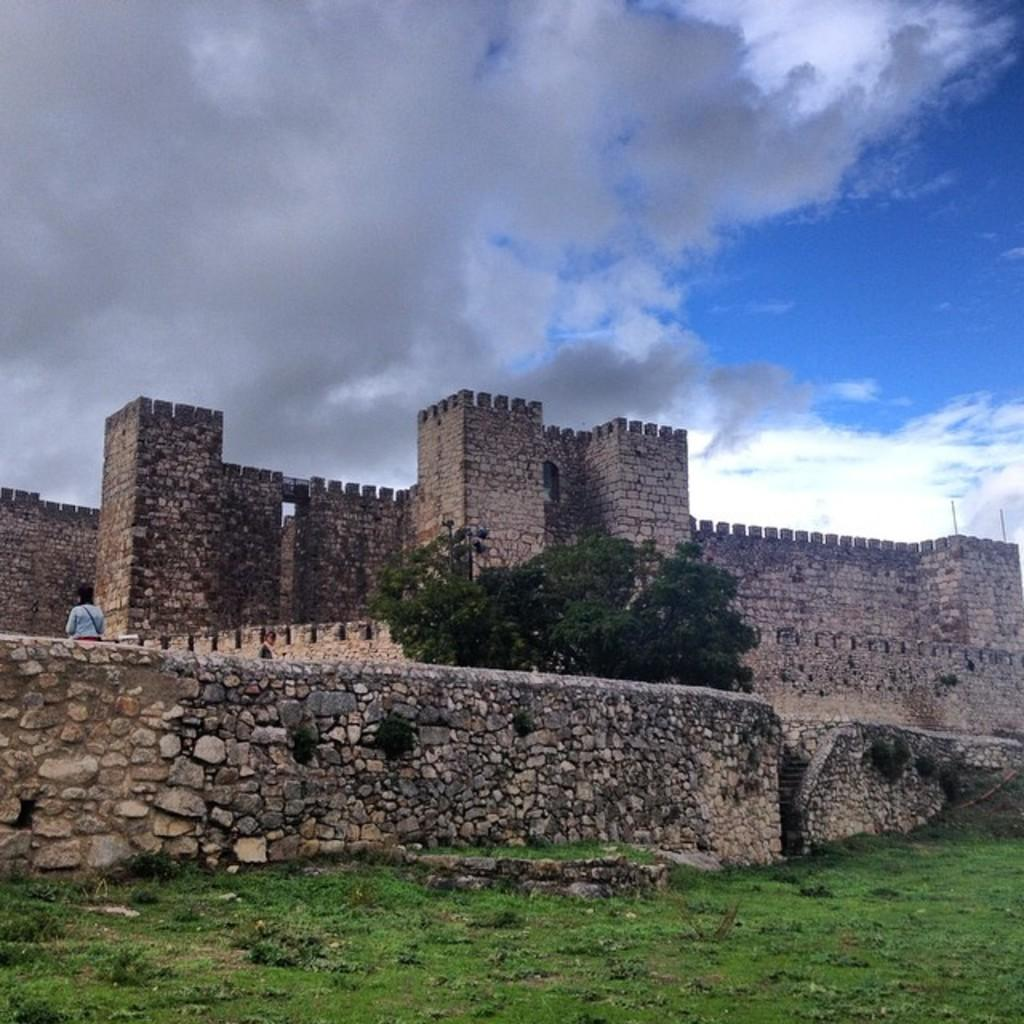What type of structure is present in the image? There is a fort in the image. What colors are used to depict the fort? The fort is in brown and black colors. Can you describe the person in the image? The person is wearing a white shirt. What type of vegetation is present in the image? There are trees in the image. What color are the trees? The trees are in green color. What is visible in the background of the image? The sky is visible in the image. What colors are used to depict the sky? The sky is in blue and white colors. What type of cork can be seen in the image? There is no cork present in the image. How does the acoustics of the fort affect the person's voice in the image? The image does not provide any information about the acoustics of the fort or the person's voice. 